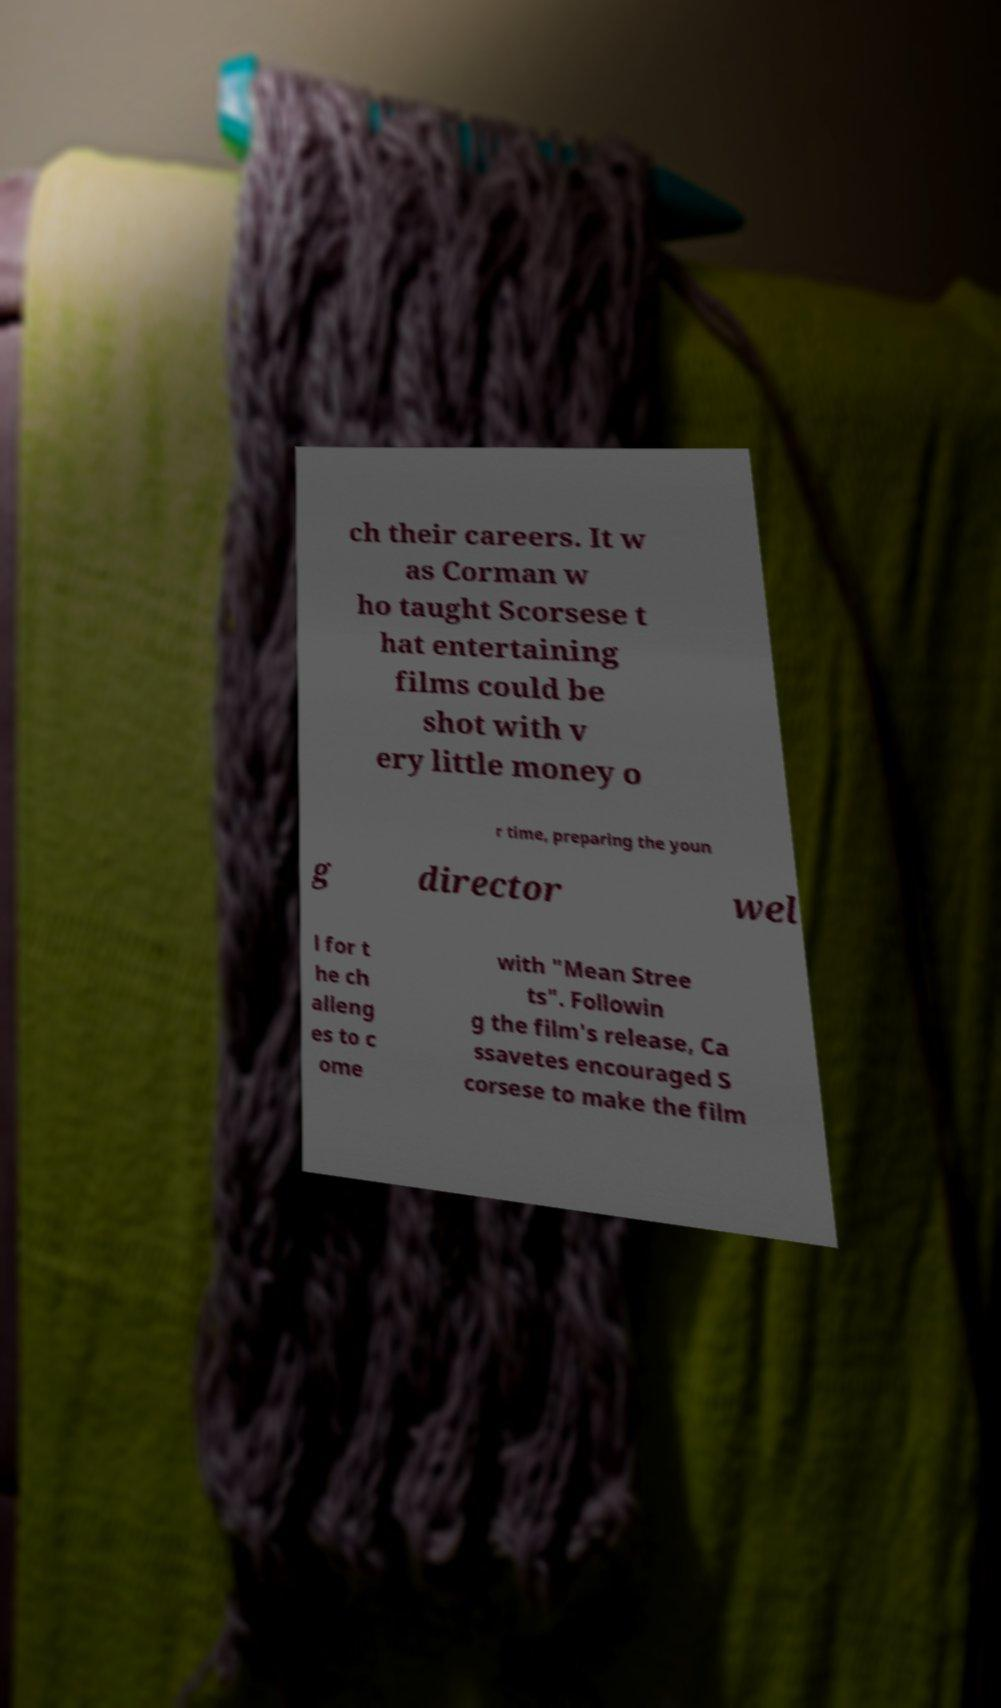I need the written content from this picture converted into text. Can you do that? ch their careers. It w as Corman w ho taught Scorsese t hat entertaining films could be shot with v ery little money o r time, preparing the youn g director wel l for t he ch alleng es to c ome with "Mean Stree ts". Followin g the film's release, Ca ssavetes encouraged S corsese to make the film 